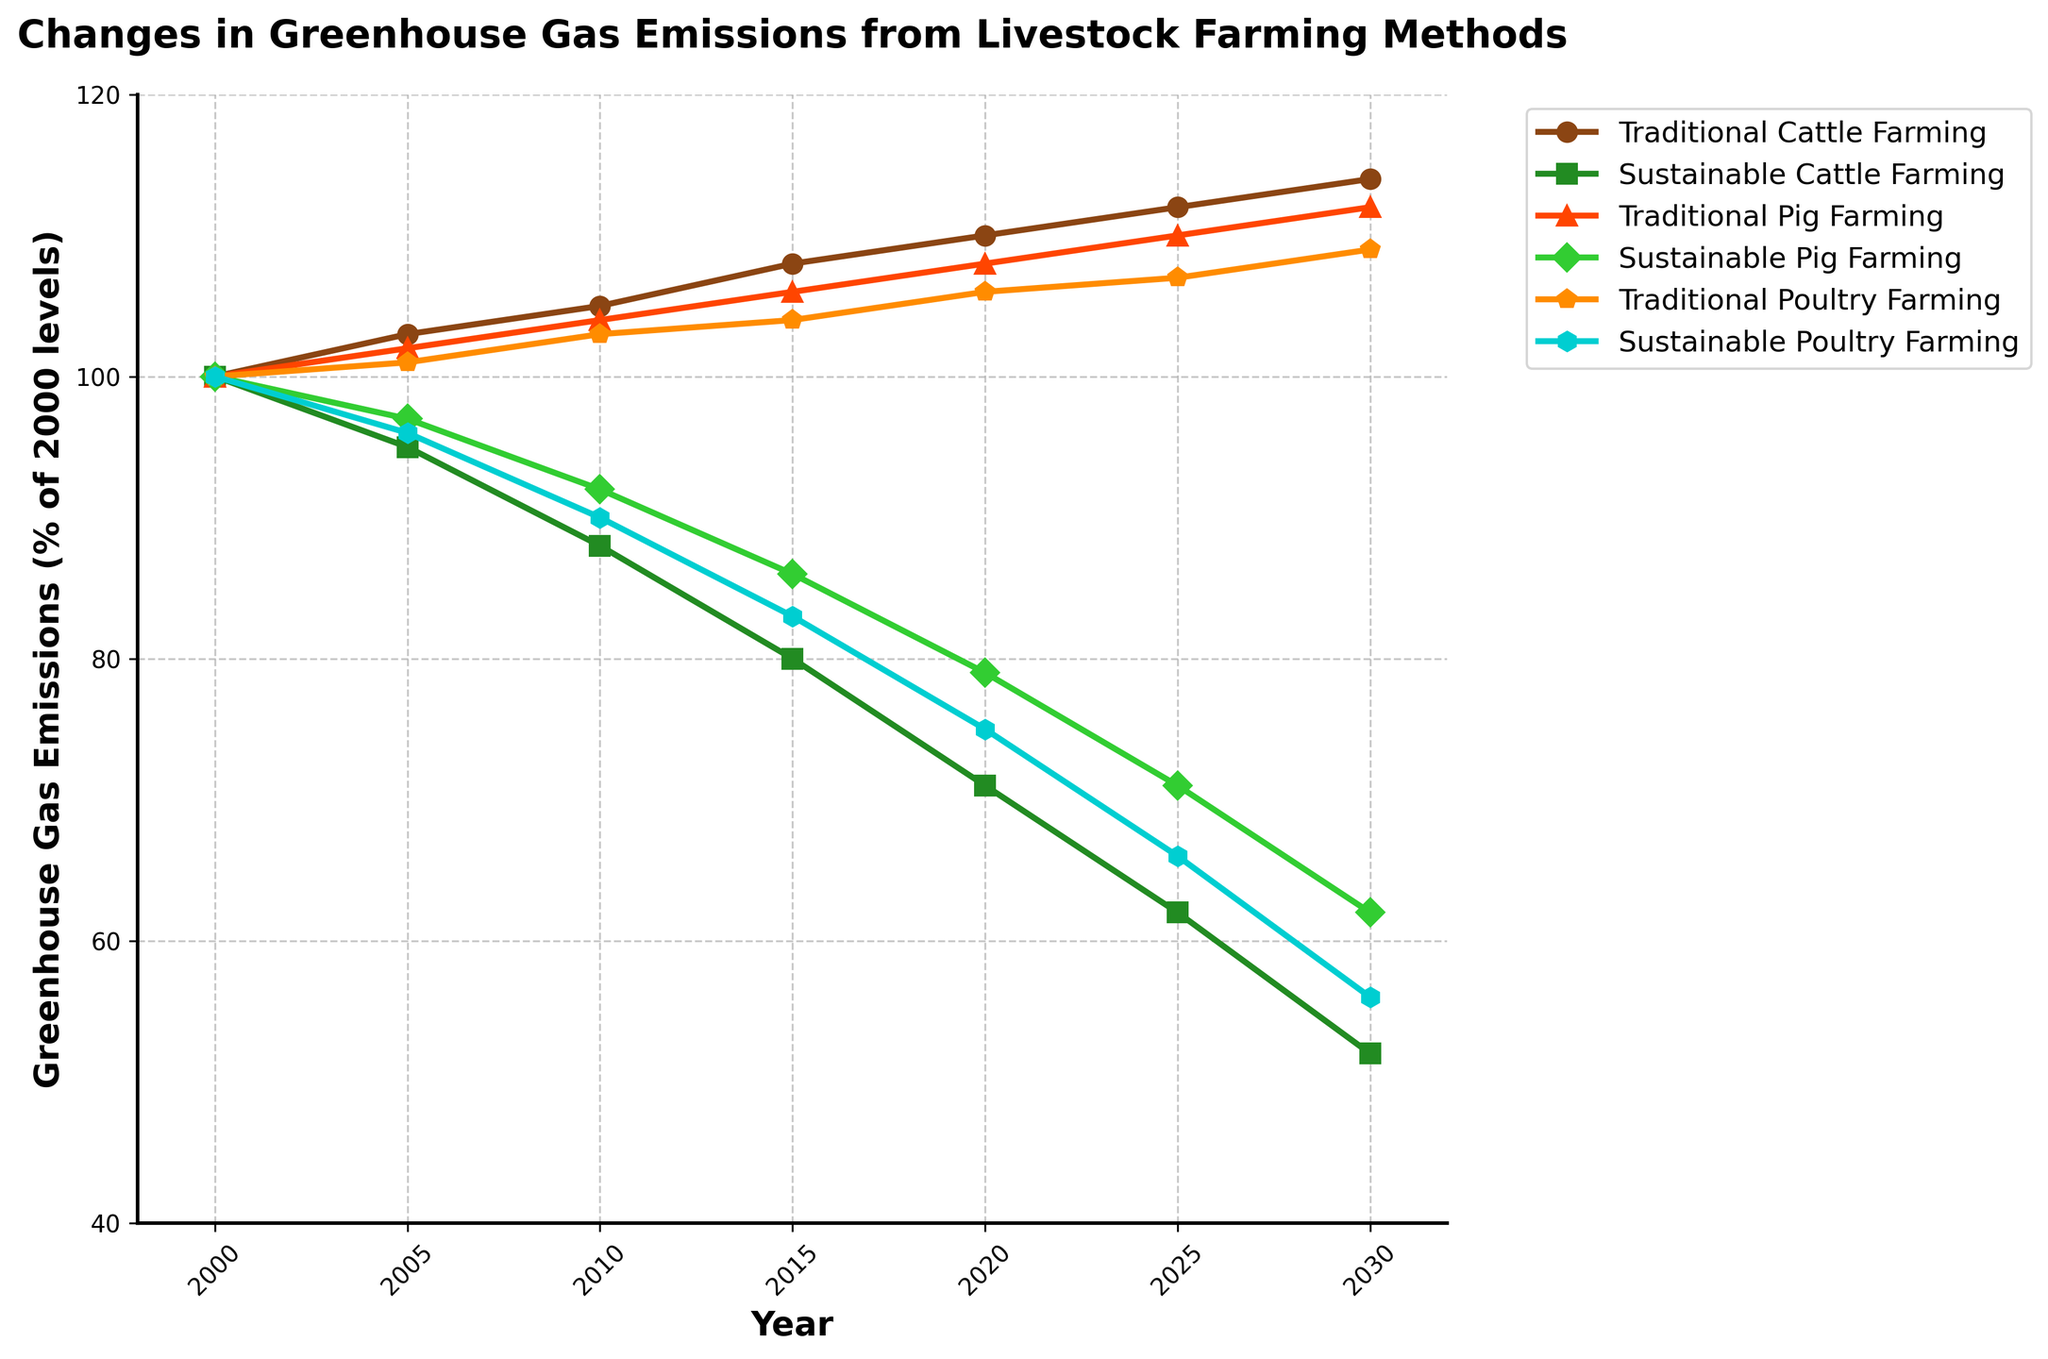what is the trend in greenhouse gas emissions for traditional cattle farming from 2000 to 2030? The figure shows the line representing traditional cattle farming emissions rising from 100 in 2000 to 114 in 2030. This indicates a steady increase over time.
Answer: increasing trend How do the greenhouse gas emissions from sustainable pig farming in 2020 compare to those in 2005? In 2005, sustainable pig farming has emissions at 97, while in 2020, emissions drop to 79. The calculation shows that emissions decreased from 97 to 79.
Answer: 18 units decrease By how much do greenhouse gas emissions from traditional poultry farming differ between the years 2015 and 2030? Emissions for traditional poultry farming are 104 in 2015 and 109 in 2030. The difference is 109 - 104 = 5 units.
Answer: 5 units difference Which farming method has shown the most significant decrease in greenhouse gas emissions from 2000 to 2030? Comparing the lines, sustainable cattle farming decreases from 100 to 52, sustainable pig farming from 100 to 62, and sustainable poultry farming from 100 to 56. Sustainable cattle farming has the largest decrease.
Answer: sustainable cattle farming What is the average greenhouse gas emissions level for sustainable poultry farming from 2010 to 2030? Emissions for sustainable poultry farming from 2010 to 2030 are (90 + 83 + 75 + 66 + 56) = 370. There are 5 data points, so the average is 370 / 5 = 74.
Answer: 74 Compare the greenhouse gas emissions for traditional vs. sustainable cattle farming in the year 2025. In 2025, emissions for traditional cattle farming are 112 while for sustainable cattle farming are 62. Comparing these shows traditional emissions are higher.
Answer: traditional cattle farming has higher emissions Which farming method has the least change in greenhouse gas emissions from 2000 to 2030? Traditional poultry farming changes from 100 to 109, a difference of 9 units, which is the smallest change compared to other methods.
Answer: traditional poultry farming What color represents sustainable cattle farming in the figure? The line for sustainable cattle farming is marked in green.
Answer: green By how much did emissions from traditional pig farming increase from 2000 to 2015? Emissions for traditional pig farming in 2000 were 100 and increased to 106 in 2015. The increase is 106 - 100 = 6 units.
Answer: 6 units increase 